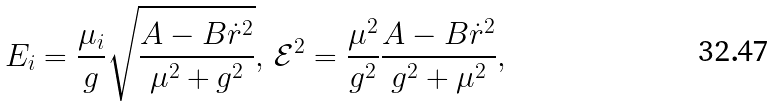Convert formula to latex. <formula><loc_0><loc_0><loc_500><loc_500>E _ { i } = \frac { \mu _ { i } } { g } \sqrt { \frac { A - B \dot { r } ^ { 2 } } { \mu ^ { 2 } + g ^ { 2 } } } , \, \mathcal { E } ^ { 2 } = \frac { \mu ^ { 2 } } { g ^ { 2 } } \frac { A - B \dot { r } ^ { 2 } } { g ^ { 2 } + \mu ^ { 2 } } ,</formula> 